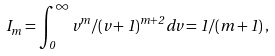Convert formula to latex. <formula><loc_0><loc_0><loc_500><loc_500>I _ { m } = \int _ { 0 } ^ { \infty } v ^ { m } / ( v + 1 ) ^ { m + 2 } \, d v = 1 / ( m + 1 ) \, ,</formula> 